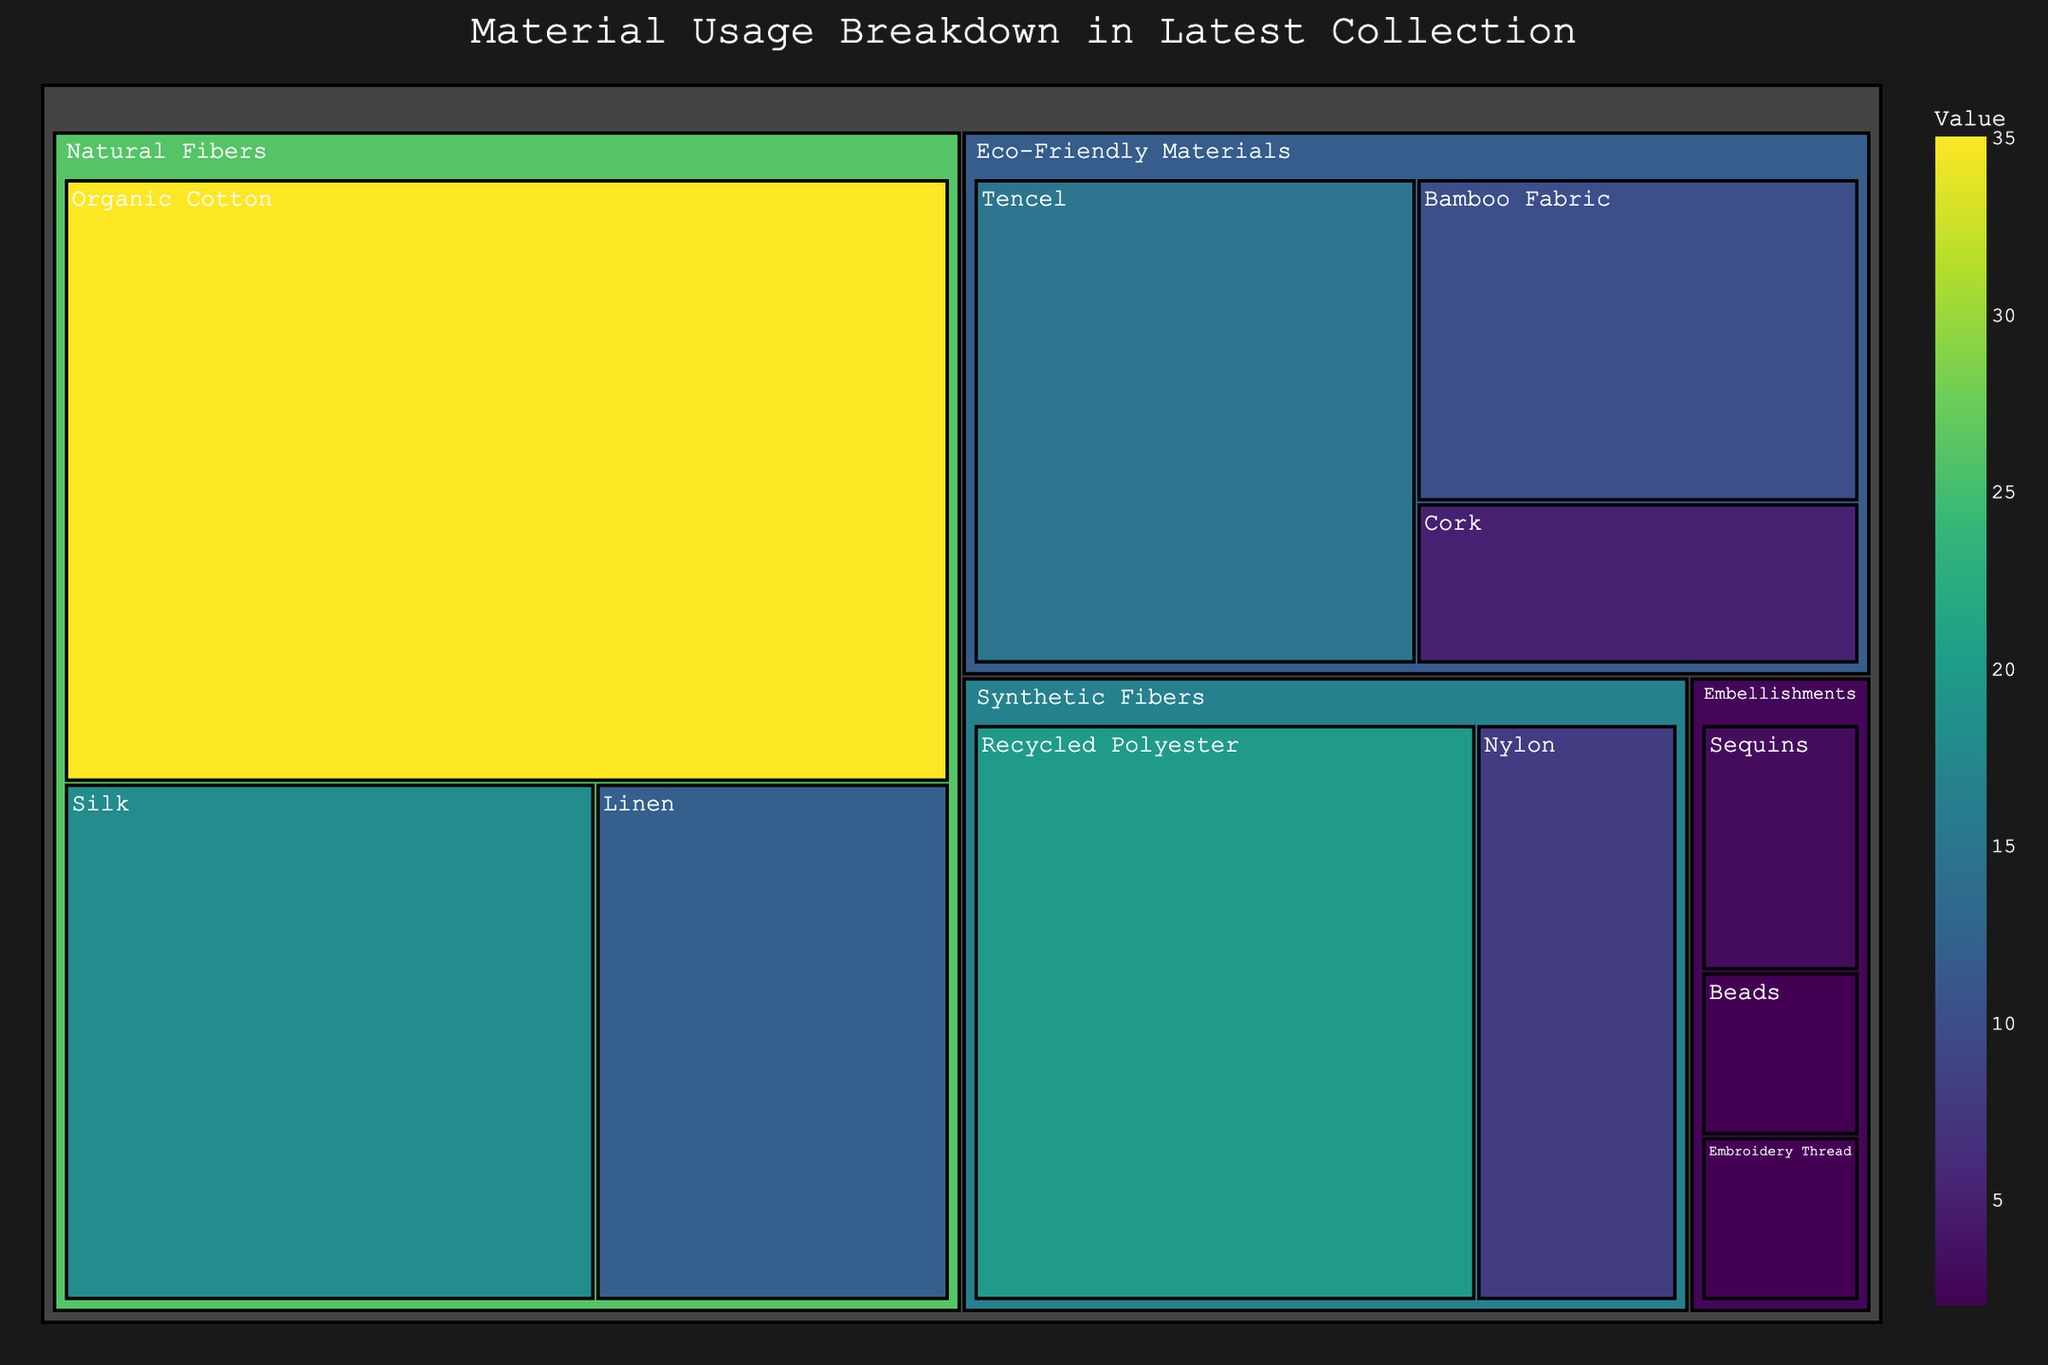What's the title of the figure? The title is usually displayed at the top of the treemap. It summarizes the subject of the visualization.
Answer: Material Usage Breakdown in Latest Collection Which subcategory has the highest value? To find the subcategory with the highest value, look for the largest tile in the treemap. The label "Organic Cotton" appears on the largest tile.
Answer: Organic Cotton How many subcategories are there under the category "Natural Fibers"? Check the treemap for the number of distinct tiles under "Natural Fibers". There are labels for Organic Cotton, Silk, and Linen under "Natural Fibers".
Answer: 3 What's the combined value for the subcategories under "Eco-Friendly Materials"? Sum the values of Tencel (15), Bamboo Fabric (10), and Cork (5). The combined value is 15 + 10 + 5.
Answer: 30 Which category has the smallest total value? Look for the category with the least total area in the treemap. Adding up the values, "Embellishments" has a total value of 3 (Sequins) + 2 (Beads) + 2 (Embroidery Thread), which totals 7.
Answer: Embellishments What is the proportion of "Recycled Polyester" compared to the total value of "Synthetic Fibers"? Calculate the percentage by dividing the value for Recycled Polyester (20) by the total value of Synthetic Fibers (20 + 8) and multiplying by 100. The calculation is (20 / (20 + 8)) * 100.
Answer: Approximately 71.4% Which category has a higher total value: "Natural Fibers" or "Synthetic Fibers"? Sum the values for each subcategory within "Natural Fibers" (35 + 18 + 12) and "Synthetic Fibers" (20 + 8). Calculate the total values as 65 and 28 respectively.
Answer: Natural Fibers How many subcategories have a value of 10 or more? Count the subcategories with values of 10 or higher: Organic Cotton (35), Silk (18), Linen (12), Recycled Polyester (20), Tencel (15), and Bamboo Fabric (10).
Answer: 6 